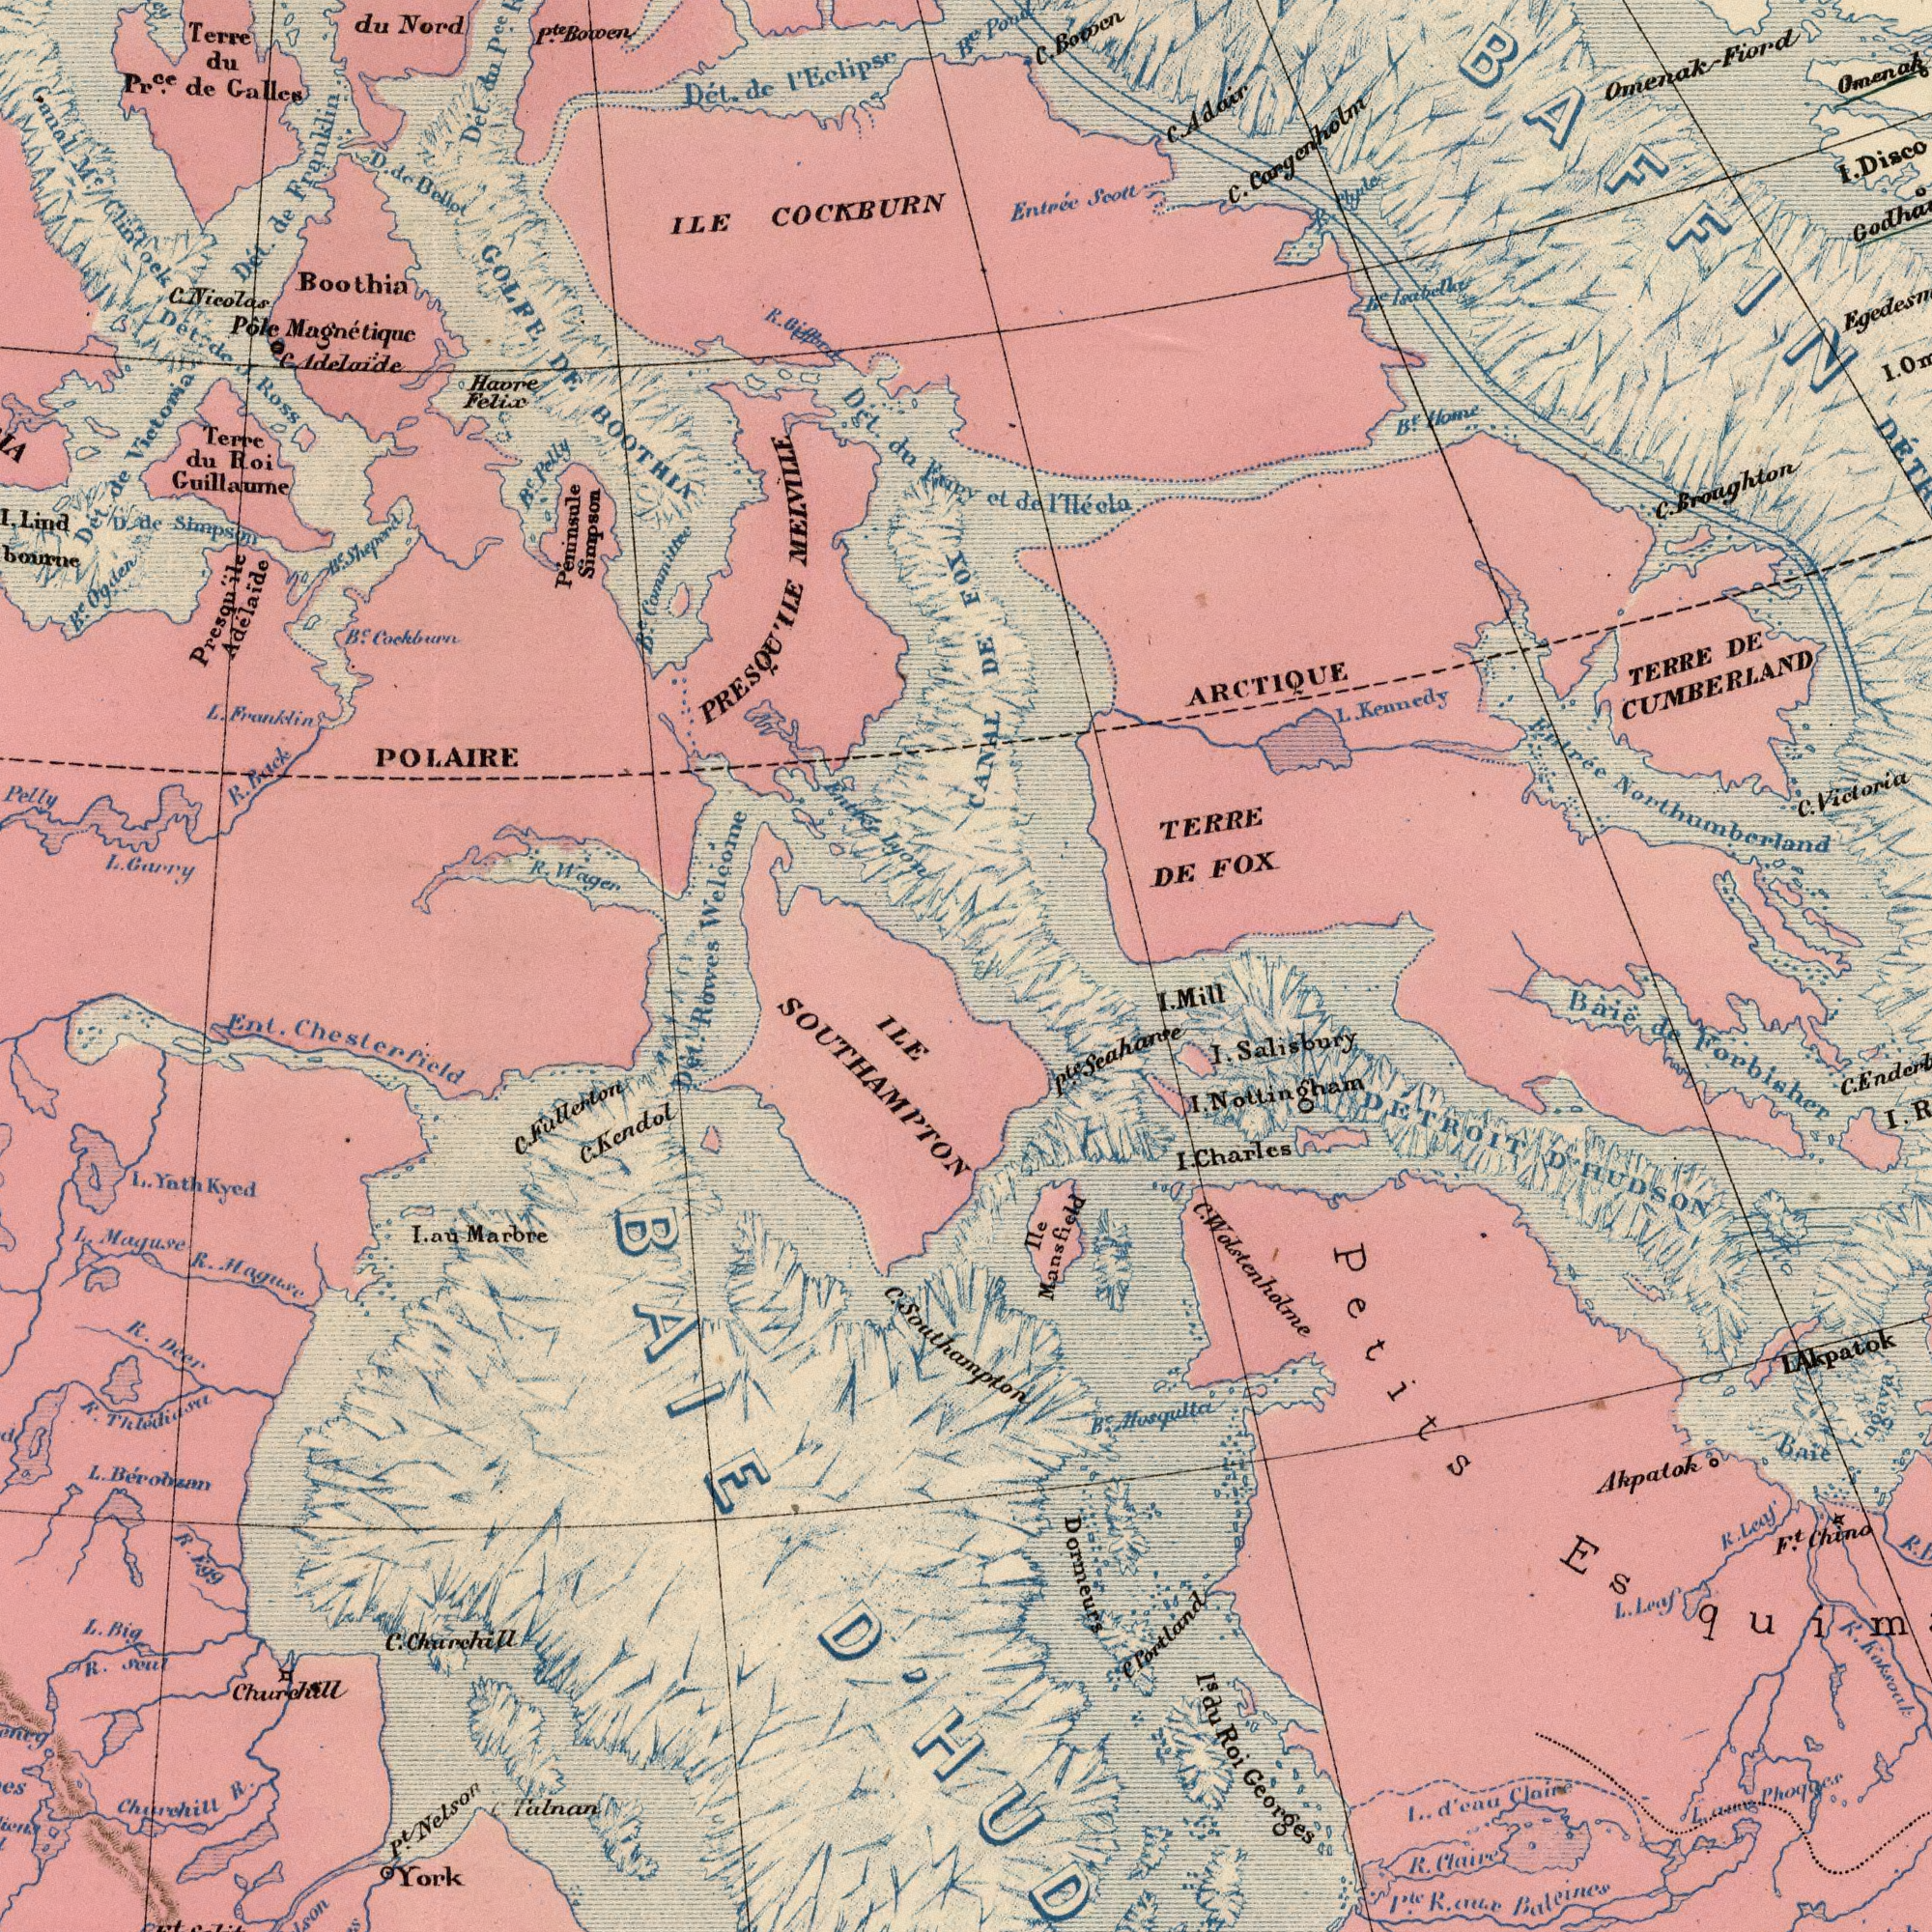What text can you see in the top-left section? Guillaume MELVILLE Ross Welcome Eelipse de ILE B<sup>c</sup>. Magnétique Canal COCKBURN DE Pôle Franklin Galles de Victoria Bellot P<sup>ce</sup>. Ogden Adélaide Nord Dét. Dét. B<sup>c</sup>. Dét. M<sup>c</sup>. Felix du Franklin Boothia Haore du Dét. Wager de Pelly Simpson P<sup>te</sup>. du Roi Pr<sup>ce</sup>. Carry Dét. PRESQU'ILE Simpson Lyon R. Adelaide Terre L. Lind Péninsule Nicolas Terre Bowen Pelly D. du Cockburn POLAIRE Clintoek R. L. de GOLFE B<sup>c</sup>. BOOTHIA C. Sheperd Funy B<sup>c</sup>. du D. Presquïle Back de I' de J. C. R. B<sup>c</sup>. What text appears in the bottom-right area of the image? DETROIT Forbisher Georges Salisbury Chino Dormeurs Petits Akpatok Ile Mill D'HUDSON Koksoak Akpatok F<sup>t</sup>. Roi Mansfield Báië B<sup>c</sup>. Portland eau Baie I. Charles Claire de Nottingham R. Claire Leaf du Musqulta R. Balcines P<sup>te</sup>. I. R. I. I. Wolstenholme Ungava R. C. L. Leaf C. I<sup>s</sup>. I. P<sup>te</sup>. C. I. I. Southampton R. ###r d' What text can you see in the bottom-left section? ILE Kendol Churchill L. R. R. R. Marbre York Ent. R. au Nelson Thleidiasu Maguse Maguse L. Churchill Bérobzan Talnan P<sup>t</sup>. R. SOUTHAMPTON Egg Chesterfield Big Fullerton Rowes Churchill L. Deer Soul Yathkyed R. C. L. C. Dét. BAIE C. C. I. What text appears in the top-right area of the image? Broughton Entrée Omenak- TERRE FOX TERRE Kennedy B<sup>e</sup>. DE DE Fiord Victoria ARCTIQUE Entréc lléola C. Scolt I. I. C. L. CANAL C. Home DE Adair Cargenholm Pond C. de R<sup>e</sup>. Clyde C. Northumberland CUMBERLAND BAFFIN B<sup>c</sup>. R. et FOX I' 